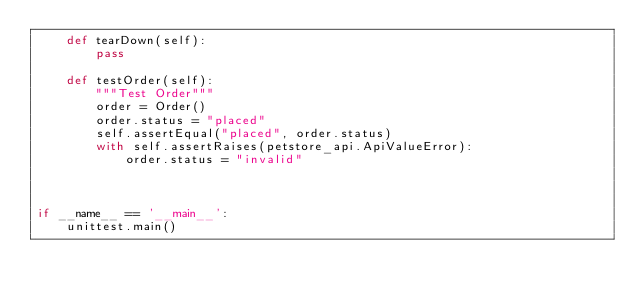Convert code to text. <code><loc_0><loc_0><loc_500><loc_500><_Python_>    def tearDown(self):
        pass

    def testOrder(self):
        """Test Order"""
        order = Order()
        order.status = "placed"
        self.assertEqual("placed", order.status)
        with self.assertRaises(petstore_api.ApiValueError):
            order.status = "invalid"



if __name__ == '__main__':
    unittest.main()
</code> 